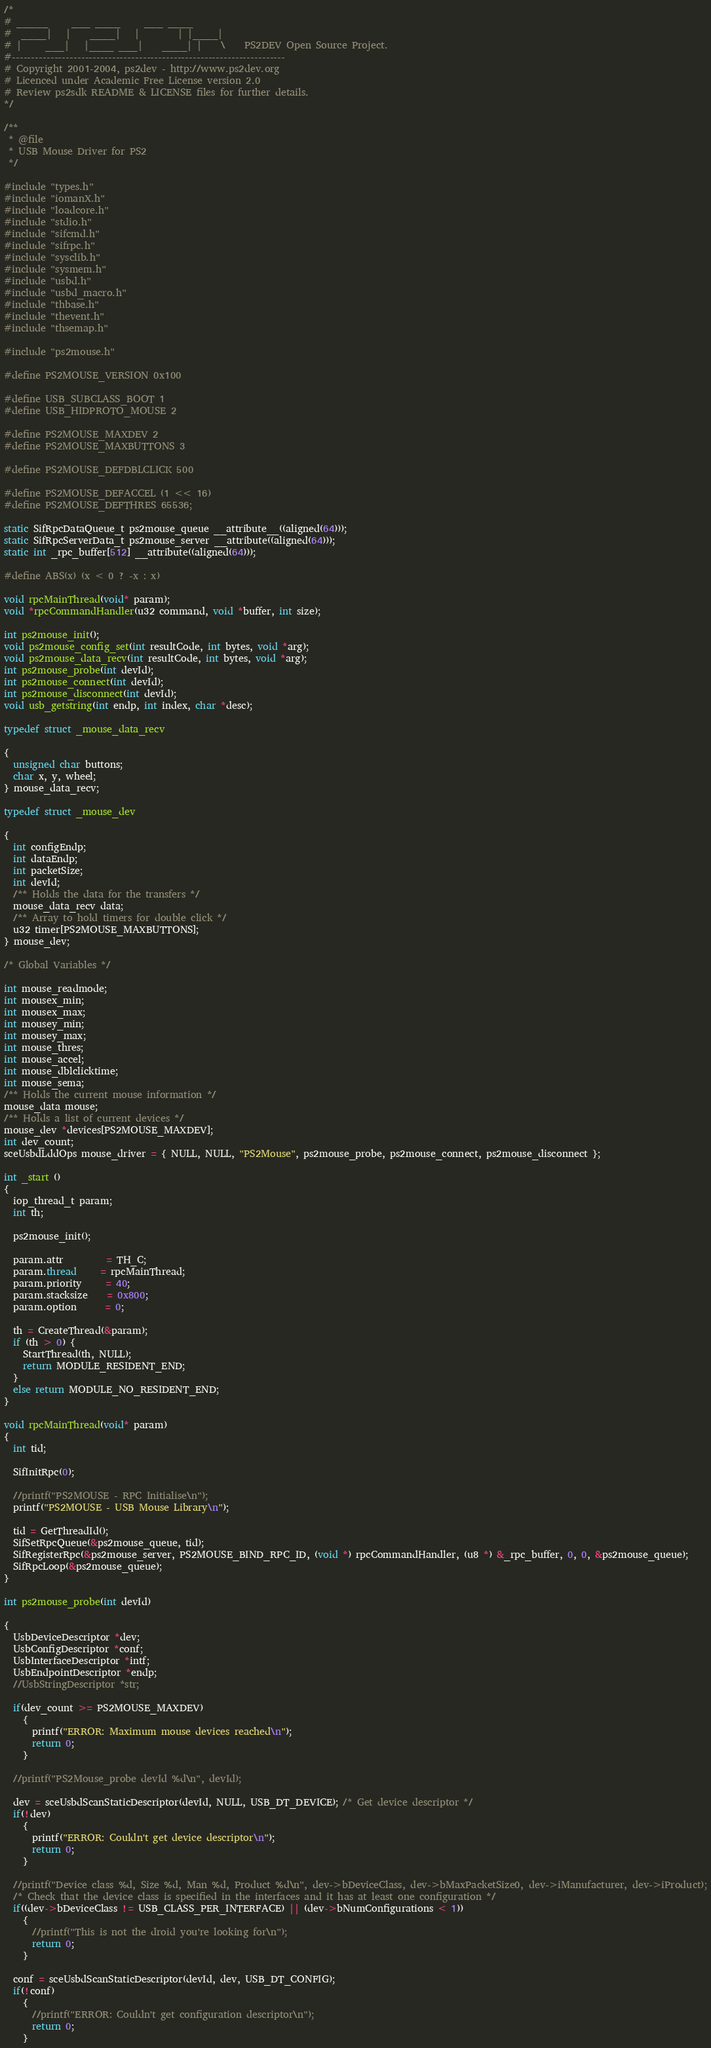Convert code to text. <code><loc_0><loc_0><loc_500><loc_500><_C_>/*
# _____     ___ ____     ___ ____
#  ____|   |    ____|   |        | |____|
# |     ___|   |____ ___|    ____| |    \    PS2DEV Open Source Project.
#-----------------------------------------------------------------------
# Copyright 2001-2004, ps2dev - http://www.ps2dev.org
# Licenced under Academic Free License version 2.0
# Review ps2sdk README & LICENSE files for further details.
*/

/**
 * @file
 * USB Mouse Driver for PS2
 */

#include "types.h"
#include "iomanX.h"
#include "loadcore.h"
#include "stdio.h"
#include "sifcmd.h"
#include "sifrpc.h"
#include "sysclib.h"
#include "sysmem.h"
#include "usbd.h"
#include "usbd_macro.h"
#include "thbase.h"
#include "thevent.h"
#include "thsemap.h"

#include "ps2mouse.h"

#define PS2MOUSE_VERSION 0x100

#define USB_SUBCLASS_BOOT 1
#define USB_HIDPROTO_MOUSE 2

#define PS2MOUSE_MAXDEV 2
#define PS2MOUSE_MAXBUTTONS 3

#define PS2MOUSE_DEFDBLCLICK 500

#define PS2MOUSE_DEFACCEL (1 << 16)
#define PS2MOUSE_DEFTHRES 65536;

static SifRpcDataQueue_t ps2mouse_queue __attribute__((aligned(64)));
static SifRpcServerData_t ps2mouse_server __attribute((aligned(64)));
static int _rpc_buffer[512] __attribute((aligned(64)));

#define ABS(x) (x < 0 ? -x : x)

void rpcMainThread(void* param);
void *rpcCommandHandler(u32 command, void *buffer, int size);

int ps2mouse_init();
void ps2mouse_config_set(int resultCode, int bytes, void *arg);
void ps2mouse_data_recv(int resultCode, int bytes, void *arg);
int ps2mouse_probe(int devId);
int ps2mouse_connect(int devId);
int ps2mouse_disconnect(int devId);
void usb_getstring(int endp, int index, char *desc);

typedef struct _mouse_data_recv

{
  unsigned char buttons;
  char x, y, wheel;
} mouse_data_recv;

typedef struct _mouse_dev

{
  int configEndp;
  int dataEndp;
  int packetSize;
  int devId;
  /** Holds the data for the transfers */
  mouse_data_recv data;
  /** Array to hold timers for double click */
  u32 timer[PS2MOUSE_MAXBUTTONS];
} mouse_dev;

/* Global Variables */

int mouse_readmode;
int mousex_min;
int mousex_max;
int mousey_min;
int mousey_max;
int mouse_thres;
int mouse_accel;
int mouse_dblclicktime;
int mouse_sema;
/** Holds the current mouse information */
mouse_data mouse;
/** Holds a list of current devices */
mouse_dev *devices[PS2MOUSE_MAXDEV];
int dev_count;
sceUsbdLddOps mouse_driver = { NULL, NULL, "PS2Mouse", ps2mouse_probe, ps2mouse_connect, ps2mouse_disconnect };

int _start ()
{
  iop_thread_t param;
  int th;

  ps2mouse_init();

  param.attr         = TH_C;
  param.thread     = rpcMainThread;
  param.priority 	 = 40;
  param.stacksize    = 0x800;
  param.option      = 0;

  th = CreateThread(&param);
  if (th > 0) {
	StartThread(th, NULL);
	return MODULE_RESIDENT_END;
  }
  else return MODULE_NO_RESIDENT_END;
}

void rpcMainThread(void* param)
{
  int tid;

  SifInitRpc(0);

  //printf("PS2MOUSE - RPC Initialise\n");
  printf("PS2MOUSE - USB Mouse Library\n");

  tid = GetThreadId();
  SifSetRpcQueue(&ps2mouse_queue, tid);
  SifRegisterRpc(&ps2mouse_server, PS2MOUSE_BIND_RPC_ID, (void *) rpcCommandHandler, (u8 *) &_rpc_buffer, 0, 0, &ps2mouse_queue);
  SifRpcLoop(&ps2mouse_queue);
}

int ps2mouse_probe(int devId)

{
  UsbDeviceDescriptor *dev;
  UsbConfigDescriptor *conf;
  UsbInterfaceDescriptor *intf;
  UsbEndpointDescriptor *endp;
  //UsbStringDescriptor *str;

  if(dev_count >= PS2MOUSE_MAXDEV)
    {
      printf("ERROR: Maximum mouse devices reached\n");
      return 0;
    }

  //printf("PS2Mouse_probe devId %d\n", devId);

  dev = sceUsbdScanStaticDescriptor(devId, NULL, USB_DT_DEVICE); /* Get device descriptor */
  if(!dev)
    {
      printf("ERROR: Couldn't get device descriptor\n");
      return 0;
    }

  //printf("Device class %d, Size %d, Man %d, Product %d\n", dev->bDeviceClass, dev->bMaxPacketSize0, dev->iManufacturer, dev->iProduct);
  /* Check that the device class is specified in the interfaces and it has at least one configuration */
  if((dev->bDeviceClass != USB_CLASS_PER_INTERFACE) || (dev->bNumConfigurations < 1))
    {
      //printf("This is not the droid you're looking for\n");
      return 0;
    }

  conf = sceUsbdScanStaticDescriptor(devId, dev, USB_DT_CONFIG);
  if(!conf)
    {
      //printf("ERROR: Couldn't get configuration descriptor\n");
      return 0;
    }</code> 